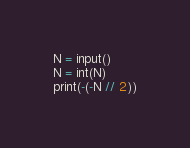Convert code to text. <code><loc_0><loc_0><loc_500><loc_500><_Python_>N = input()
N = int(N)
print(-(-N // 2))</code> 